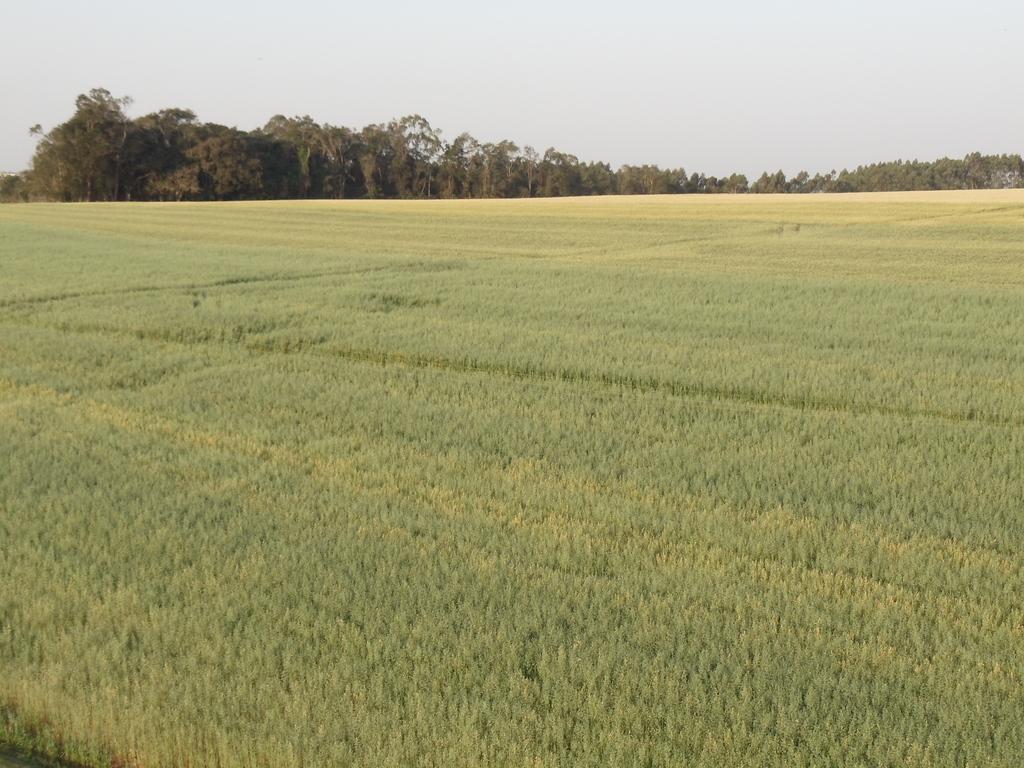Describe this image in one or two sentences. In this image we can see the acres of the form. In the background there are trees. At the bottom there is grass. 